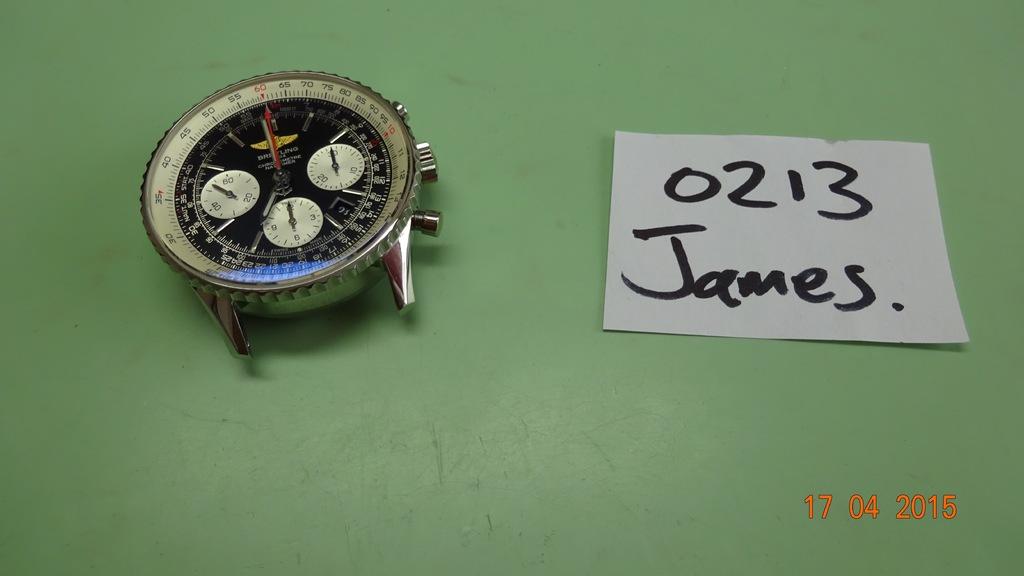Who is this watchpiece for?
Keep it short and to the point. James. What is the number above the name?
Keep it short and to the point. 0213. 